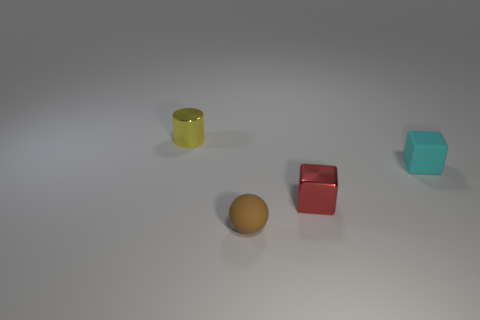How many other objects are the same shape as the brown rubber object?
Keep it short and to the point. 0. There is a tiny metal thing that is in front of the yellow metallic cylinder; does it have the same shape as the small object that is on the left side of the tiny brown object?
Ensure brevity in your answer.  No. Are there the same number of brown spheres that are behind the small yellow thing and tiny spheres that are on the left side of the cyan cube?
Keep it short and to the point. No. There is a tiny metallic object behind the cyan rubber thing that is behind the shiny thing in front of the small yellow shiny thing; what shape is it?
Offer a terse response. Cylinder. Are the small thing behind the cyan rubber object and the small thing in front of the small red metallic thing made of the same material?
Ensure brevity in your answer.  No. There is a tiny thing that is to the left of the brown matte thing; what is its shape?
Give a very brief answer. Cylinder. Are there fewer tiny blocks than cyan matte things?
Make the answer very short. No. Are there any objects in front of the metallic thing that is in front of the thing that is left of the brown ball?
Offer a terse response. Yes. How many metallic things are cubes or small cylinders?
Your response must be concise. 2. How many small metal things are left of the small red cube?
Provide a short and direct response. 1. 